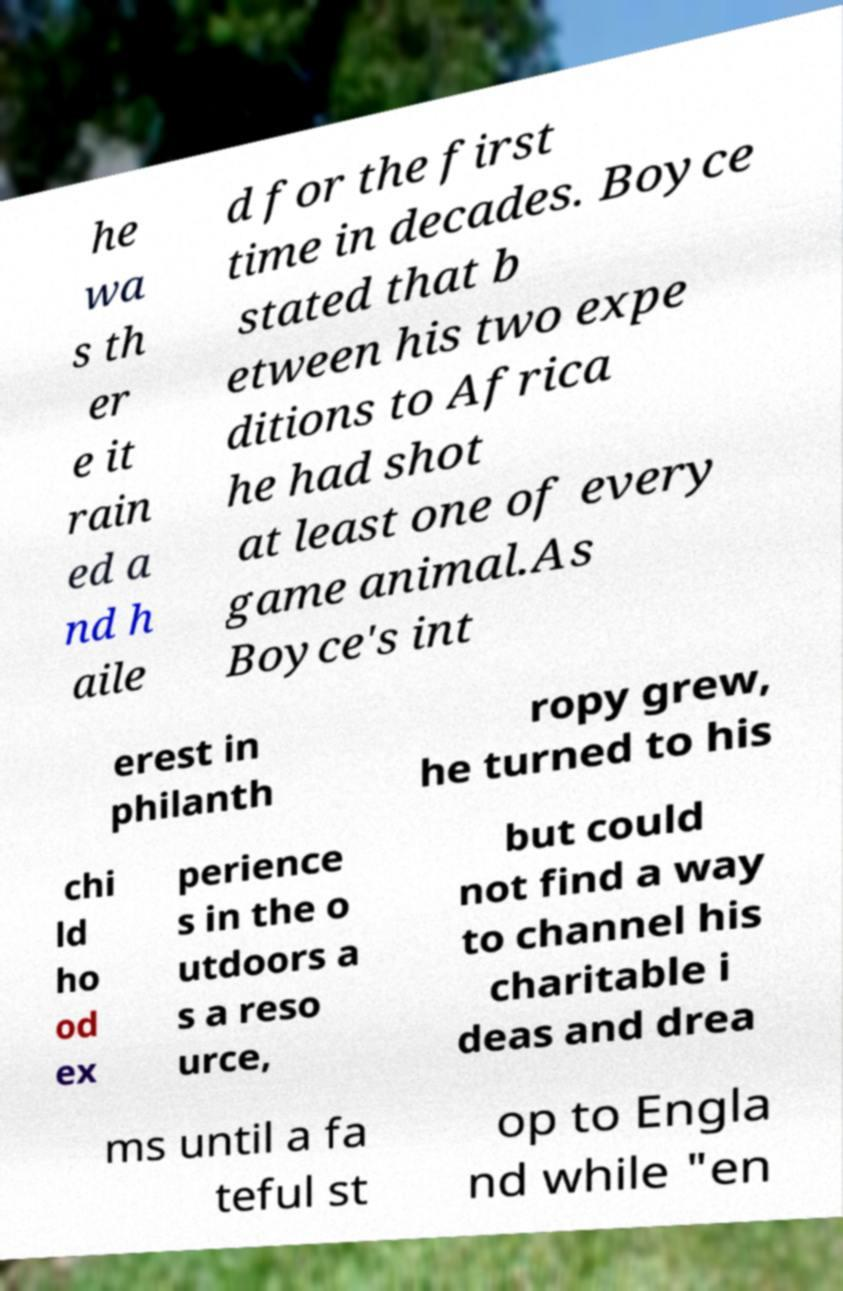Could you assist in decoding the text presented in this image and type it out clearly? he wa s th er e it rain ed a nd h aile d for the first time in decades. Boyce stated that b etween his two expe ditions to Africa he had shot at least one of every game animal.As Boyce's int erest in philanth ropy grew, he turned to his chi ld ho od ex perience s in the o utdoors a s a reso urce, but could not find a way to channel his charitable i deas and drea ms until a fa teful st op to Engla nd while "en 